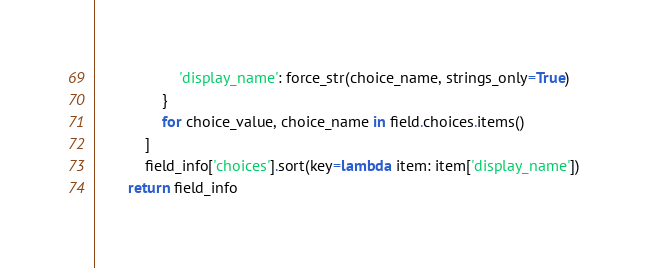<code> <loc_0><loc_0><loc_500><loc_500><_Python_>                    'display_name': force_str(choice_name, strings_only=True)
                }
                for choice_value, choice_name in field.choices.items()
            ]
            field_info['choices'].sort(key=lambda item: item['display_name'])
        return field_info
</code> 